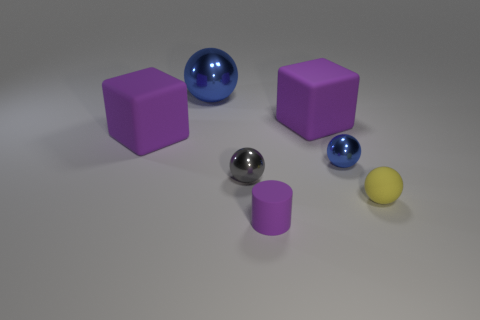How big is the purple rubber thing that is to the right of the small matte thing on the left side of the yellow sphere?
Ensure brevity in your answer.  Large. The gray shiny object that is to the left of the big matte cube behind the large rubber block that is left of the small gray sphere is what shape?
Keep it short and to the point. Sphere. What is the color of the sphere that is the same material as the purple cylinder?
Offer a very short reply. Yellow. What color is the shiny object that is behind the blue metal thing that is on the right side of the metallic ball that is behind the small blue thing?
Make the answer very short. Blue. What number of cylinders are either purple matte objects or green matte objects?
Give a very brief answer. 1. There is a small thing that is the same color as the large sphere; what material is it?
Keep it short and to the point. Metal. Do the big metal sphere and the small cylinder in front of the yellow object have the same color?
Your answer should be compact. No. What is the color of the large metal thing?
Your answer should be compact. Blue. How many things are either big green cubes or small rubber things?
Your answer should be compact. 2. There is a yellow thing that is the same size as the matte cylinder; what material is it?
Keep it short and to the point. Rubber. 